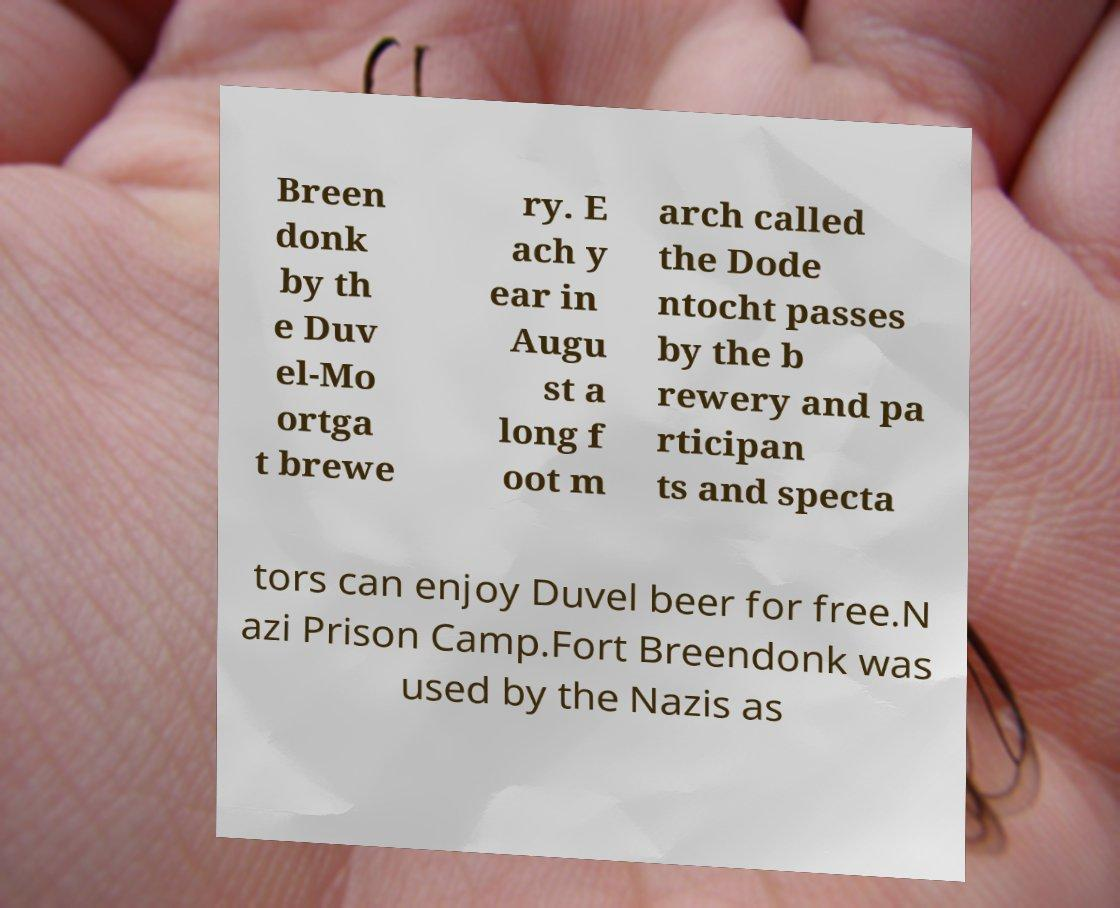I need the written content from this picture converted into text. Can you do that? Breen donk by th e Duv el-Mo ortga t brewe ry. E ach y ear in Augu st a long f oot m arch called the Dode ntocht passes by the b rewery and pa rticipan ts and specta tors can enjoy Duvel beer for free.N azi Prison Camp.Fort Breendonk was used by the Nazis as 